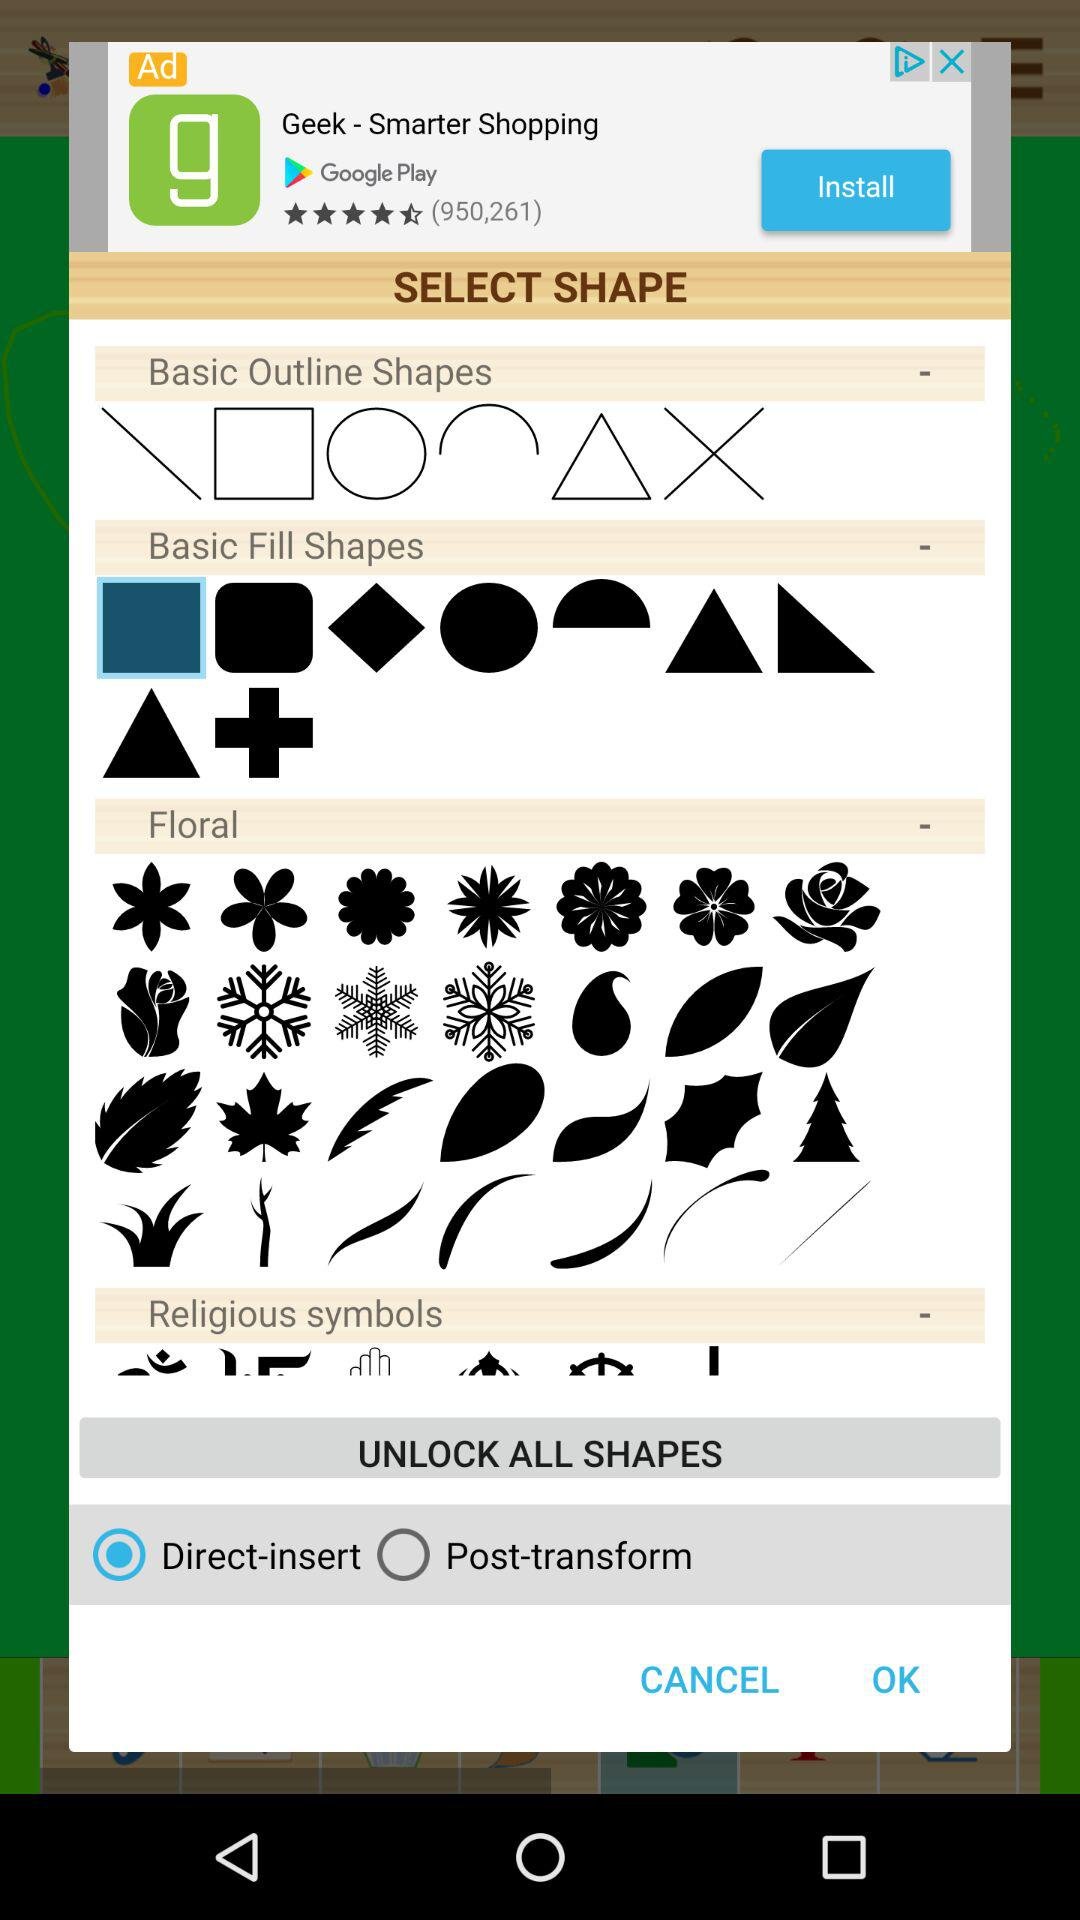How many shape categories are there?
Answer the question using a single word or phrase. 4 